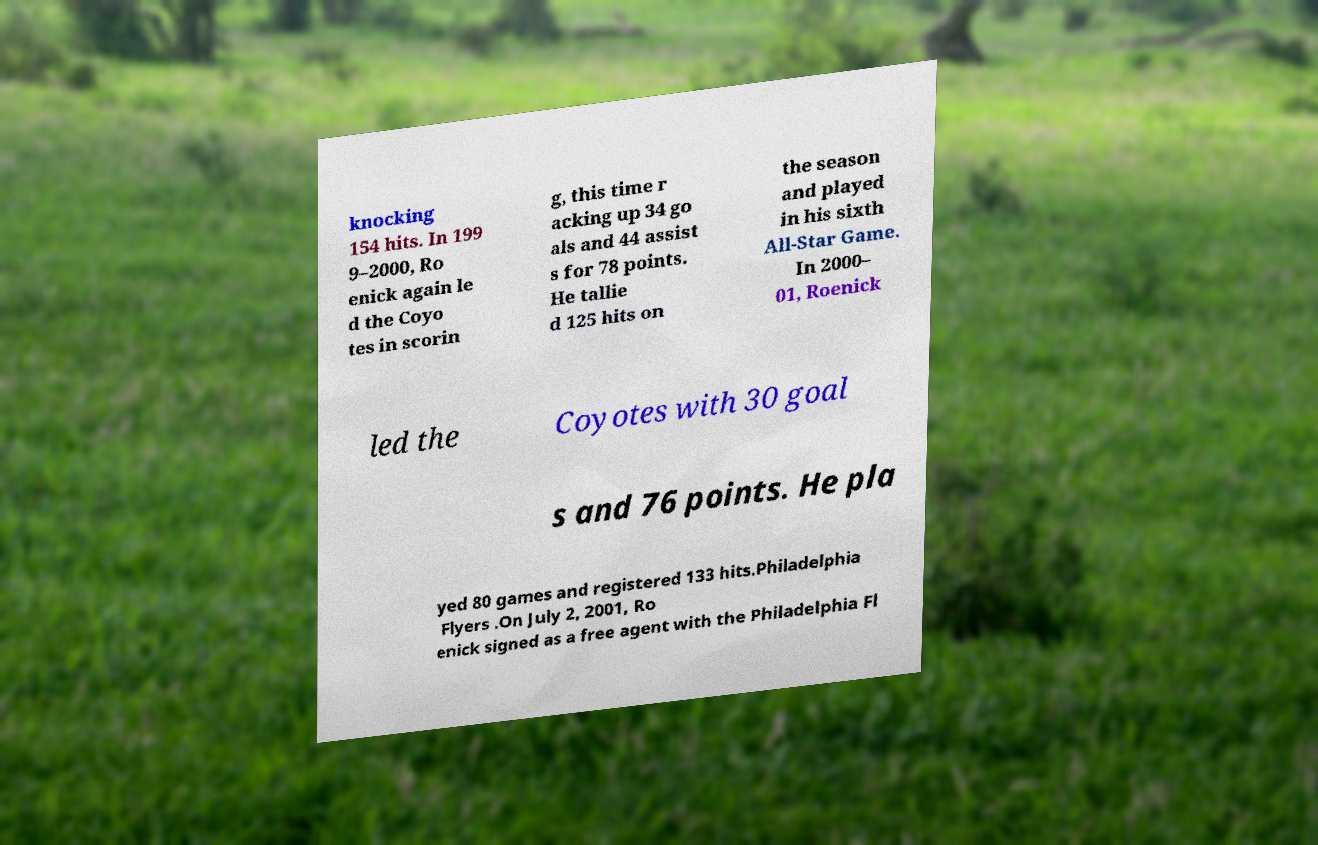There's text embedded in this image that I need extracted. Can you transcribe it verbatim? knocking 154 hits. In 199 9–2000, Ro enick again le d the Coyo tes in scorin g, this time r acking up 34 go als and 44 assist s for 78 points. He tallie d 125 hits on the season and played in his sixth All-Star Game. In 2000– 01, Roenick led the Coyotes with 30 goal s and 76 points. He pla yed 80 games and registered 133 hits.Philadelphia Flyers .On July 2, 2001, Ro enick signed as a free agent with the Philadelphia Fl 